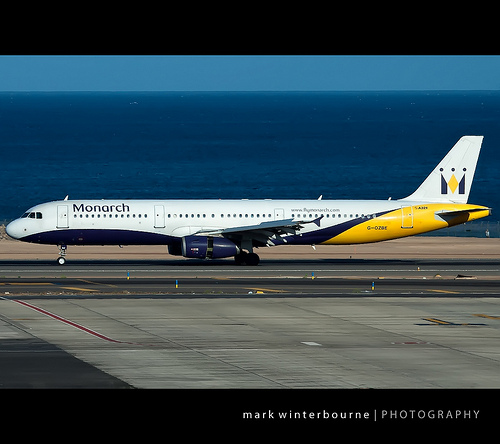Please provide a short description for this region: [0.8, 0.45, 0.9, 0.54]. The tail section of the plane, which is prominently yellow. 